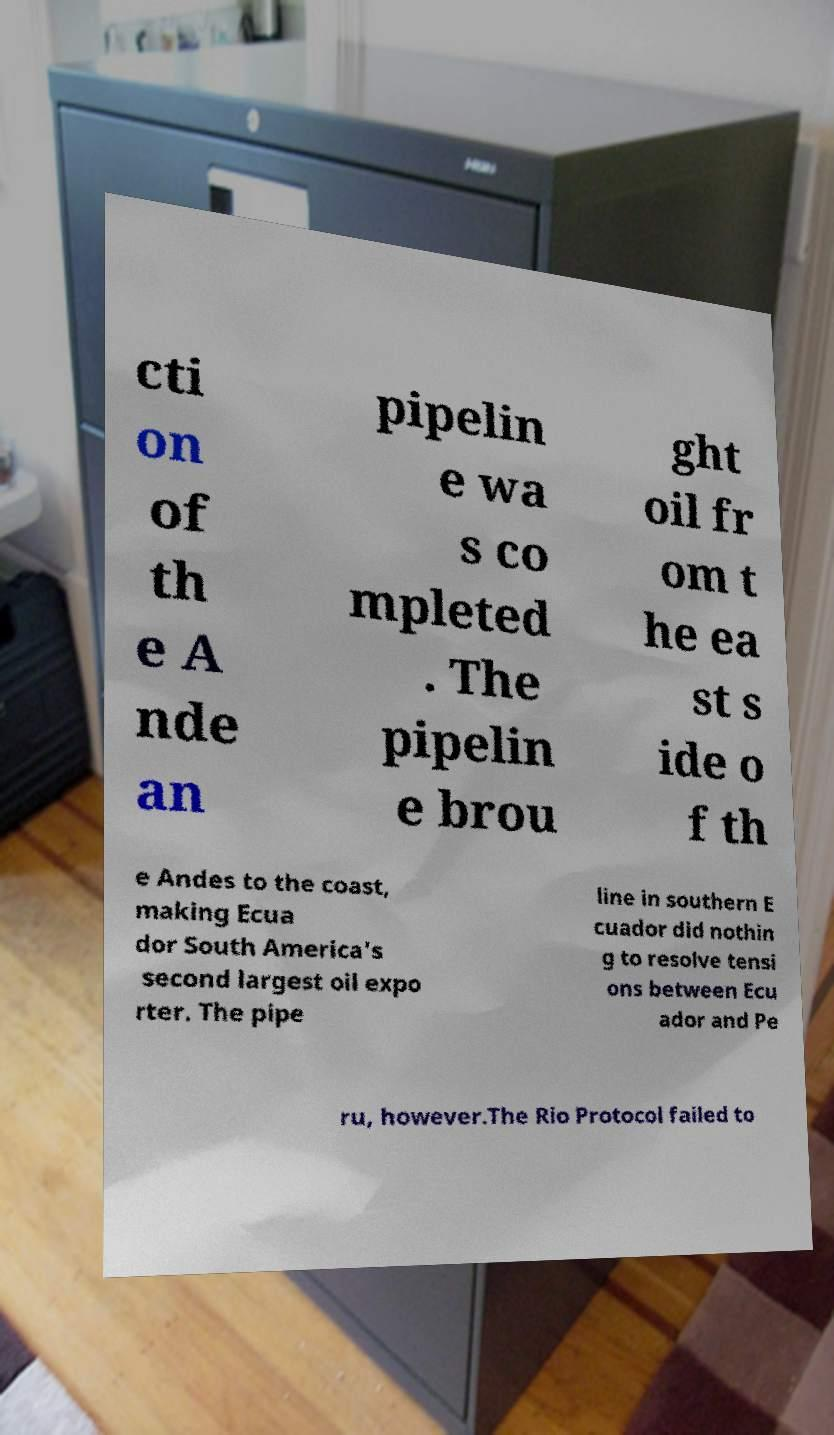There's text embedded in this image that I need extracted. Can you transcribe it verbatim? cti on of th e A nde an pipelin e wa s co mpleted . The pipelin e brou ght oil fr om t he ea st s ide o f th e Andes to the coast, making Ecua dor South America's second largest oil expo rter. The pipe line in southern E cuador did nothin g to resolve tensi ons between Ecu ador and Pe ru, however.The Rio Protocol failed to 